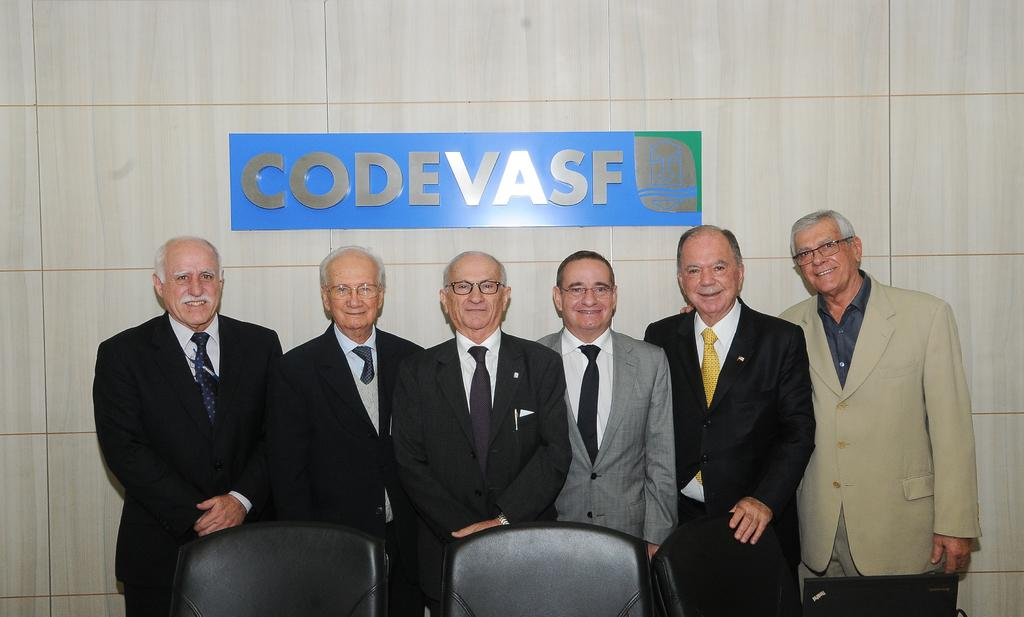What are the persons in the image wearing? The persons in the image are wearing suits. What is the facial expression of the persons in the image? The persons are smiling in the image. What position are the persons in the image? The persons are standing in the image. How many chairs are arranged in the image? There are two chairs arranged in the image. What electronic device is present in the image? There is a laptop in the image. What can be seen attached to the wall in the background of the image? There is a hoarding attached to the wall in the background of the image. What month is being celebrated in the image? There is no indication of a specific month being celebrated in the image. What type of note is being passed between the persons in the image? There is no note being passed between the persons in the image. 